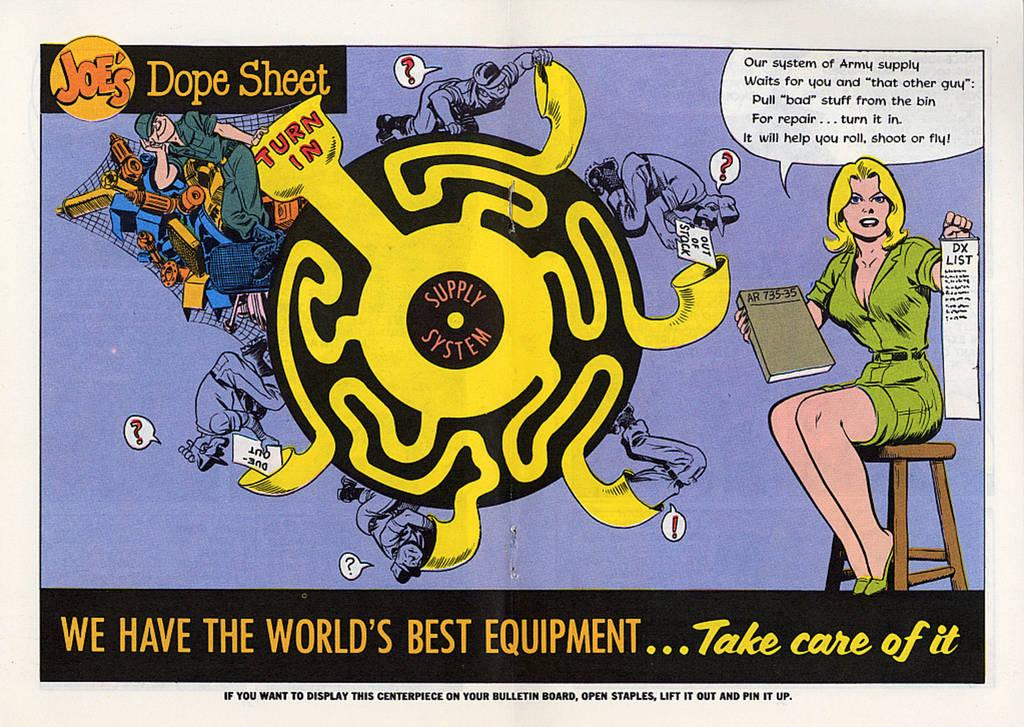<image>
Write a terse but informative summary of the picture. A comic book panel says Joe's Dope Sheet and has a maze on it. 